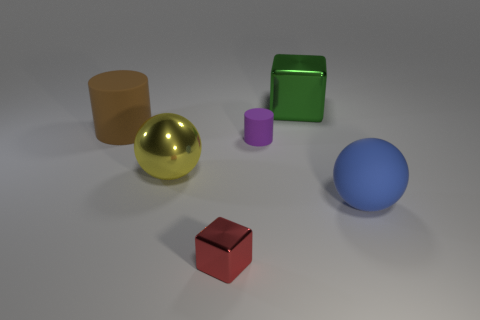What number of other things are there of the same color as the small block?
Provide a short and direct response. 0. There is a tiny thing that is in front of the big sphere to the right of the large cube; is there a green thing behind it?
Offer a terse response. Yes. What is the shape of the rubber thing that is behind the large blue ball and to the right of the tiny metallic object?
Provide a succinct answer. Cylinder. Are there any tiny metal things that have the same color as the metal sphere?
Your answer should be compact. No. The cube in front of the rubber cylinder that is in front of the large brown matte cylinder is what color?
Offer a terse response. Red. What is the size of the matte object that is on the right side of the tiny thing behind the big rubber object right of the tiny red block?
Offer a terse response. Large. Are the large block and the ball on the right side of the small purple cylinder made of the same material?
Offer a terse response. No. What is the size of the brown object that is the same material as the big blue sphere?
Make the answer very short. Large. Is there a tiny object of the same shape as the large green thing?
Your answer should be compact. Yes. What number of things are cylinders behind the big blue ball or gray matte cubes?
Provide a short and direct response. 2. 